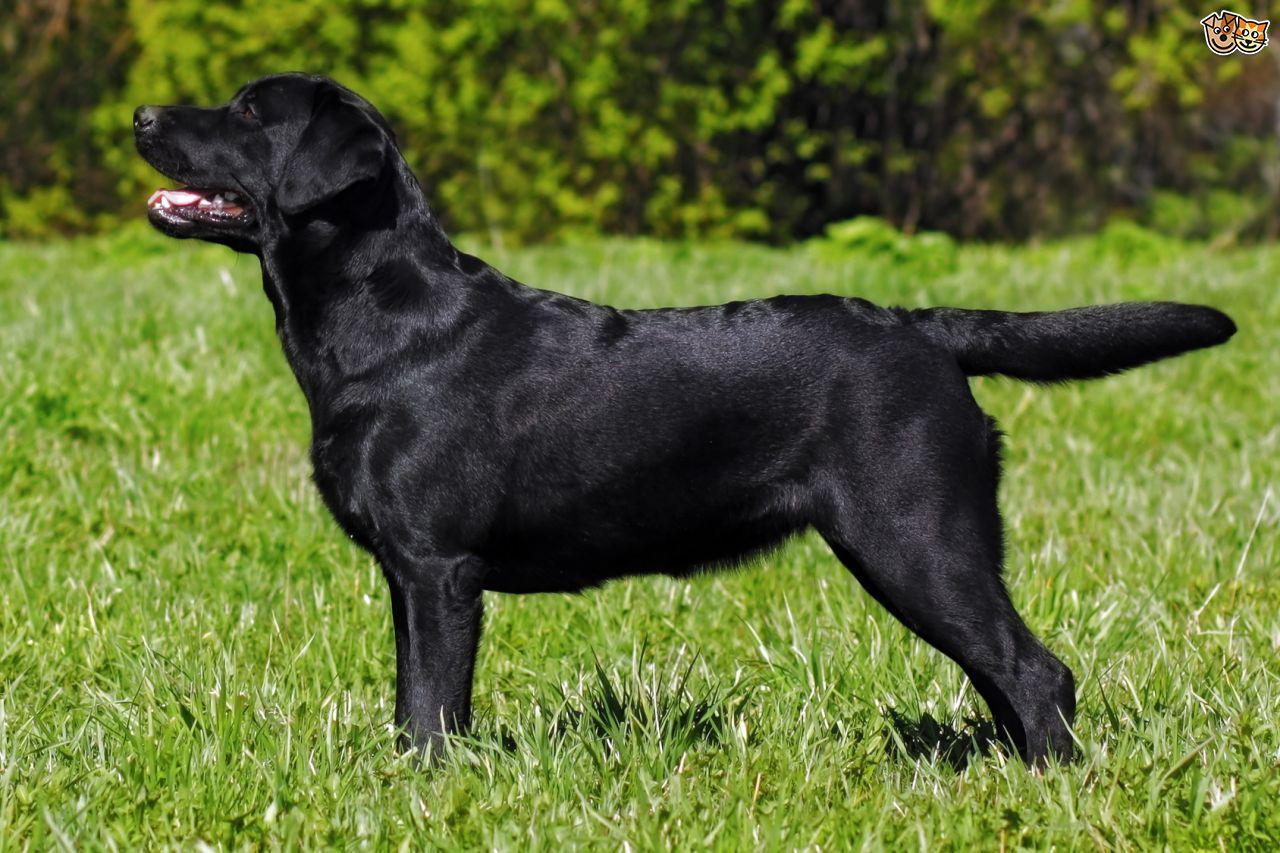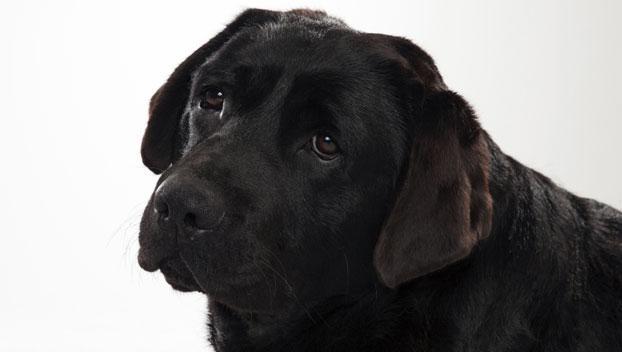The first image is the image on the left, the second image is the image on the right. Examine the images to the left and right. Is the description "Both images contain a dark colored dog." accurate? Answer yes or no. Yes. The first image is the image on the left, the second image is the image on the right. Considering the images on both sides, is "Both dogs are facing opposite directions." valid? Answer yes or no. No. 